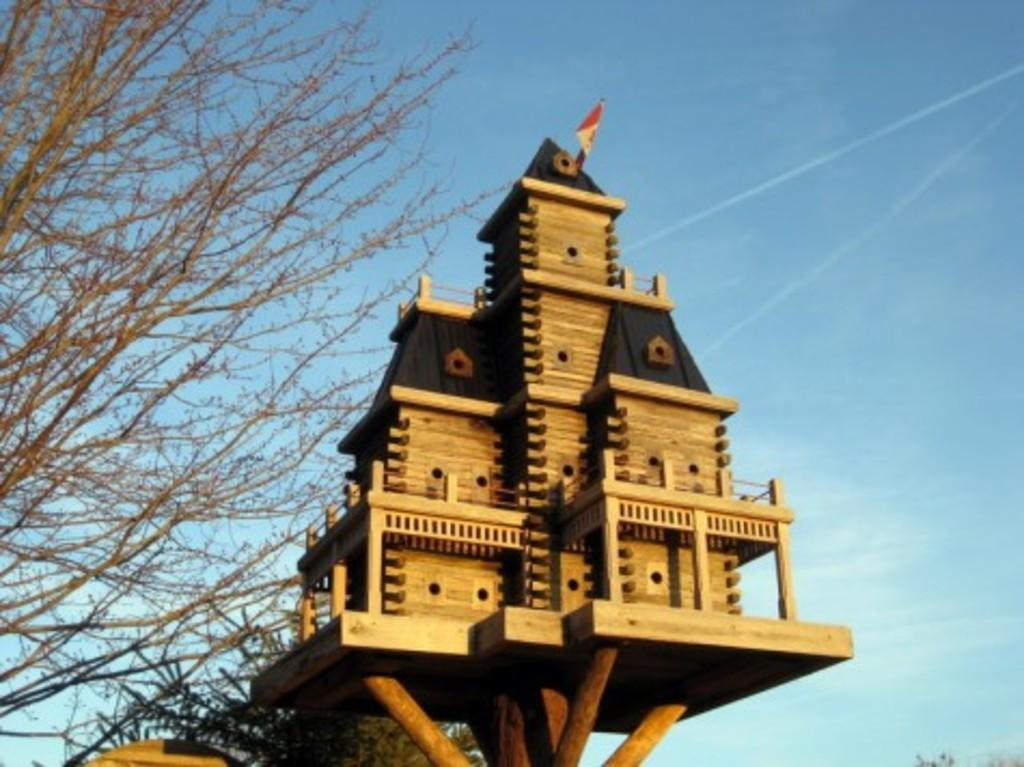What type of structure is located in the middle of the image? There is a small wooden house in the middle of the image. What can be seen on the left side of the image? There are trees on the left side of the image. What is visible at the top of the image? The sky is visible at the top of the image. What historical event is depicted in the image? There is no historical event depicted in the image; it features a small wooden house, trees, and the sky. How many spiders can be seen crawling on the wooden house in the image? There are no spiders present in the image. 